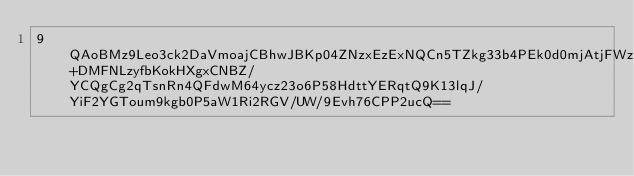Convert code to text. <code><loc_0><loc_0><loc_500><loc_500><_SML_>9QAoBMz9Leo3ck2DaVmoajCBhwJBKp04ZNzxEzExNQCn5TZkg33b4PEk0d0mjAtjFWzYfQMRIgaZlNBE688FIQ2IQhrC+DMFNLzyfbKokHXgxCNBZ/YCQgCg2qTsnRn4QFdwM64ycz23o6P58HdttYERqtQ9K13lqJ/YiF2YGToum9kgb0P5aW1Ri2RGV/UW/9Evh76CPP2ucQ==</code> 